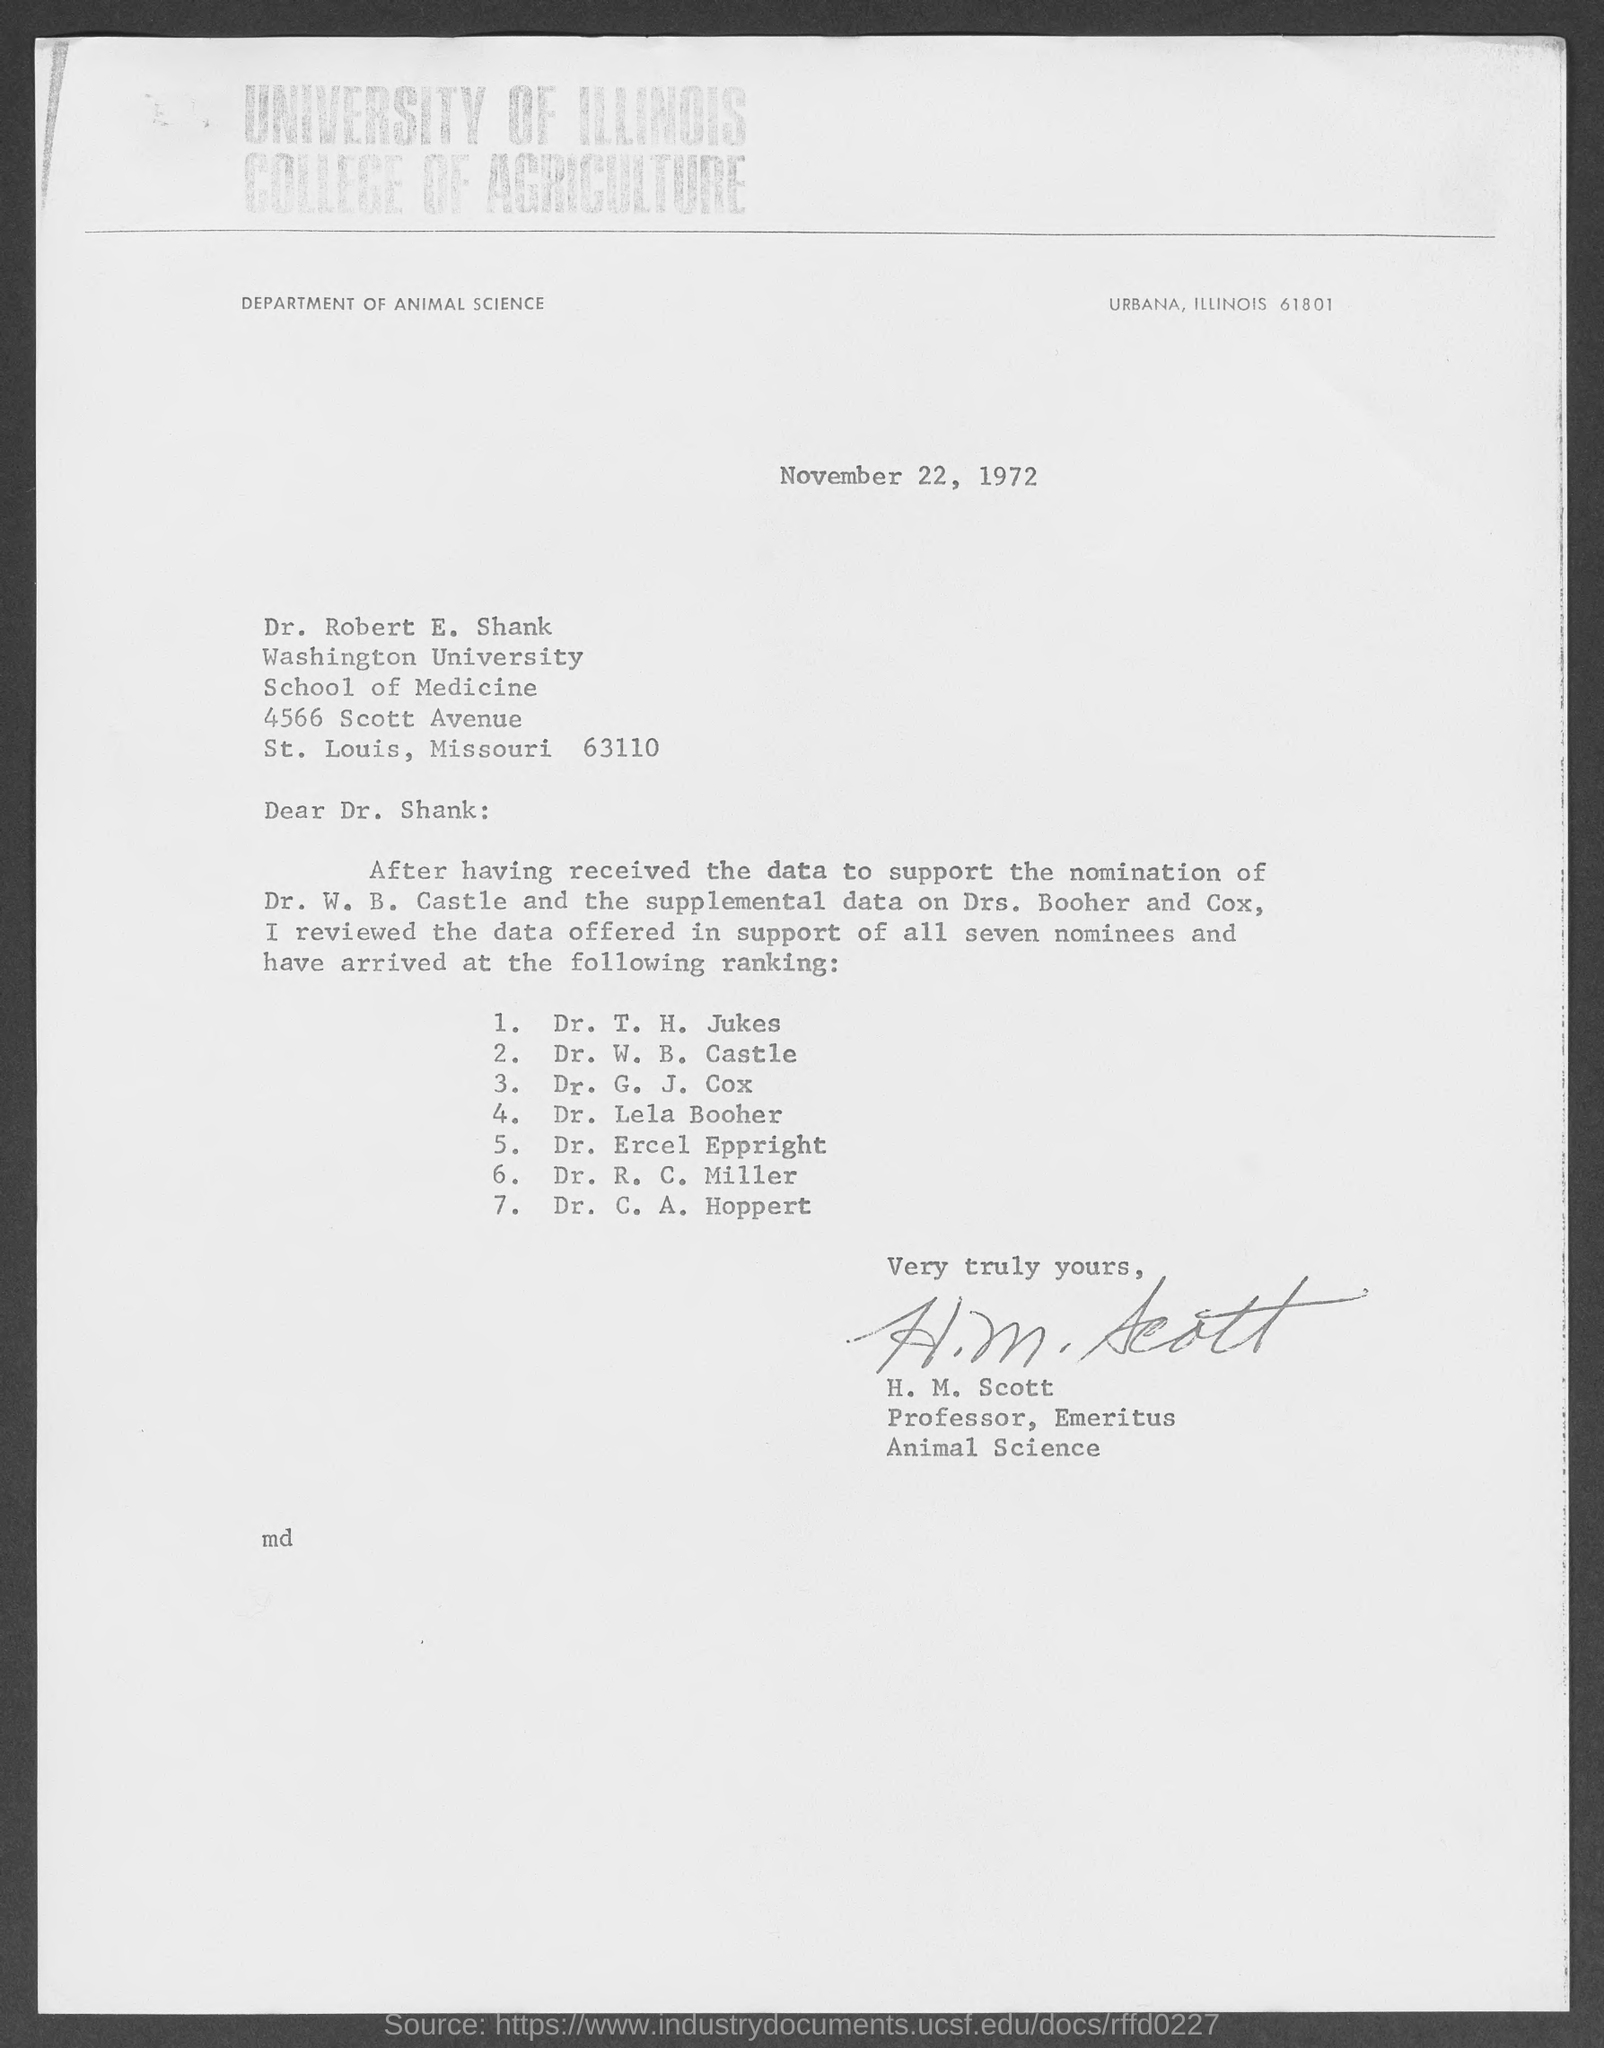To which university does dr.robert e. shank belong?
Ensure brevity in your answer.  Washington university. Who wrote this letter?
Provide a short and direct response. H. m. scott. The letter is dated on?
Your answer should be very brief. November 22, 1972. 